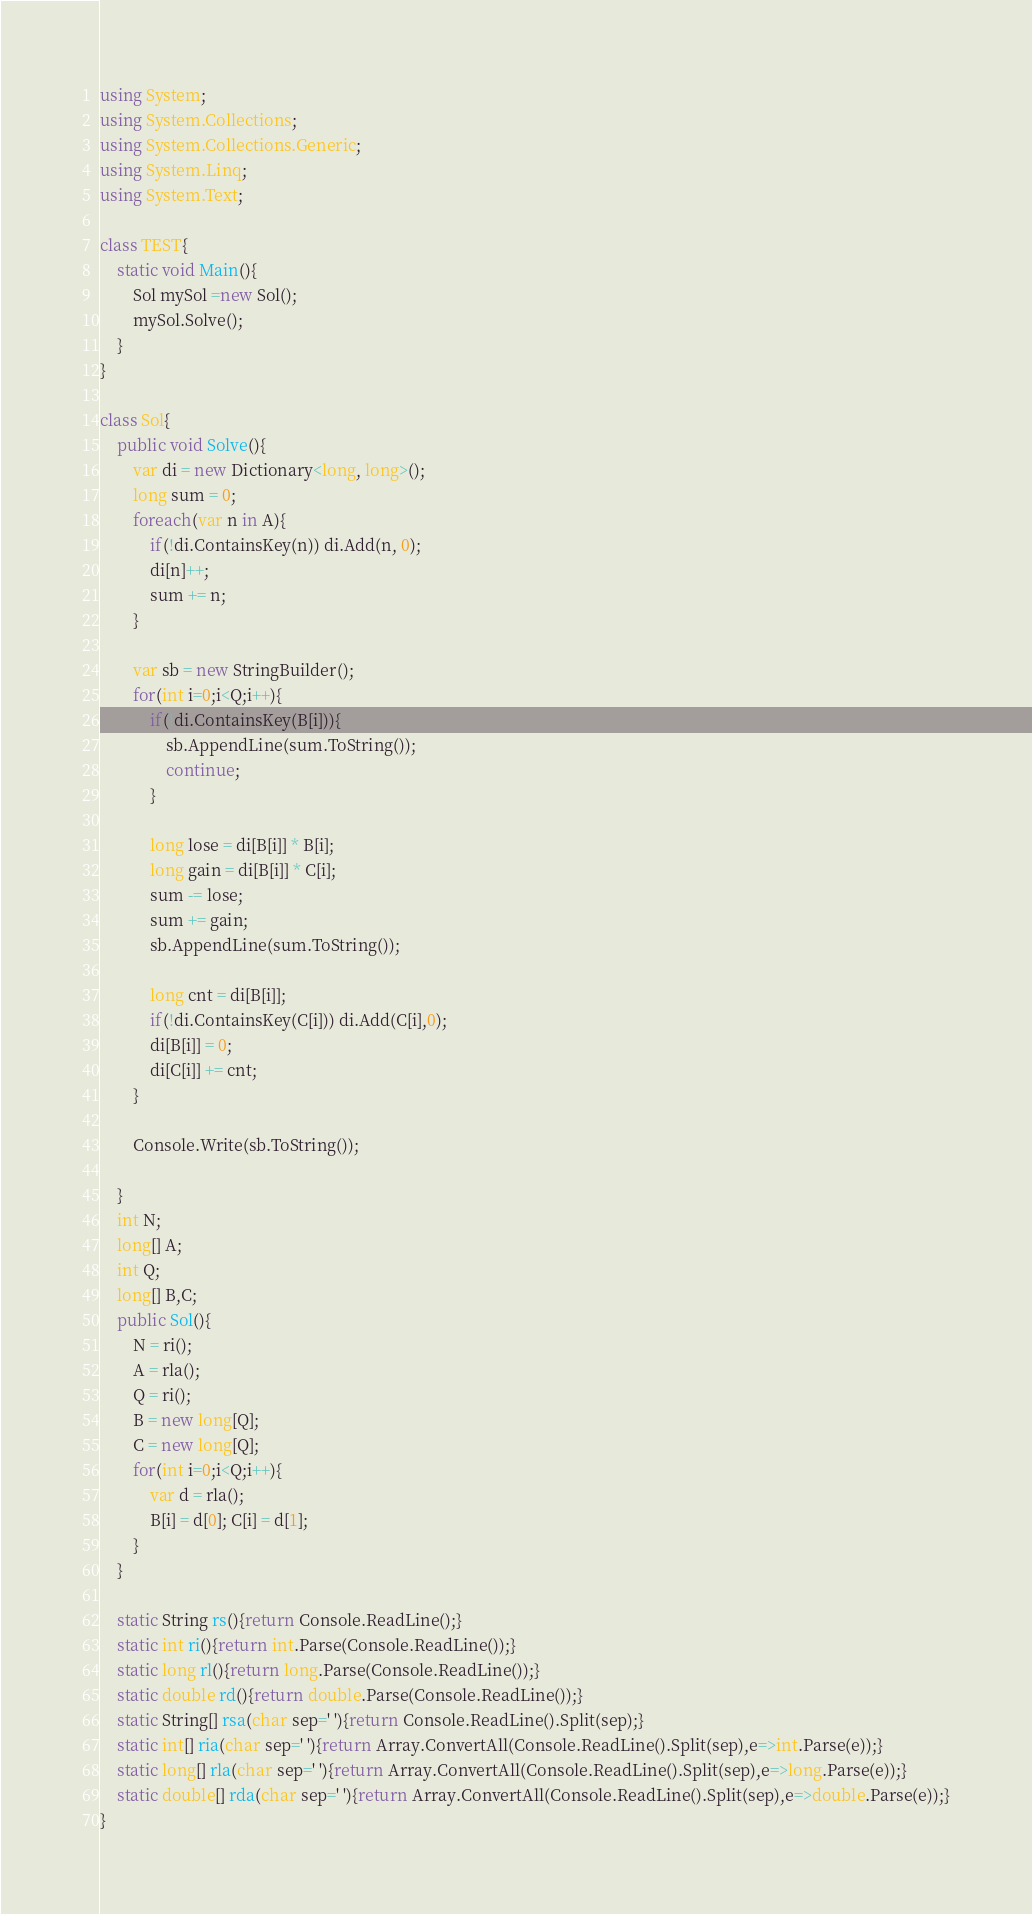<code> <loc_0><loc_0><loc_500><loc_500><_C#_>using System;
using System.Collections;
using System.Collections.Generic;
using System.Linq;
using System.Text;

class TEST{
	static void Main(){
		Sol mySol =new Sol();
		mySol.Solve();
	}
}

class Sol{
	public void Solve(){
		var di = new Dictionary<long, long>();
		long sum = 0;
		foreach(var n in A){
			if(!di.ContainsKey(n)) di.Add(n, 0);
			di[n]++;
			sum += n;
		}
		
		var sb = new StringBuilder();
		for(int i=0;i<Q;i++){
			if(!di.ContainsKey(B[i])){
				sb.AppendLine(sum.ToString());
				continue;
			}
			
			long lose = di[B[i]] * B[i];
			long gain = di[B[i]] * C[i];
			sum -= lose;
			sum += gain;
			sb.AppendLine(sum.ToString());
			
			long cnt = di[B[i]];
			if(!di.ContainsKey(C[i])) di.Add(C[i],0);
			di[B[i]] = 0;
			di[C[i]] += cnt;
		}
		
		Console.Write(sb.ToString());
		
	}
	int N;
	long[] A;
	int Q;
	long[] B,C;
	public Sol(){
		N = ri();
		A = rla();
		Q = ri();
		B = new long[Q];
		C = new long[Q];
		for(int i=0;i<Q;i++){
			var d = rla();
			B[i] = d[0]; C[i] = d[1];
		}
	}

	static String rs(){return Console.ReadLine();}
	static int ri(){return int.Parse(Console.ReadLine());}
	static long rl(){return long.Parse(Console.ReadLine());}
	static double rd(){return double.Parse(Console.ReadLine());}
	static String[] rsa(char sep=' '){return Console.ReadLine().Split(sep);}
	static int[] ria(char sep=' '){return Array.ConvertAll(Console.ReadLine().Split(sep),e=>int.Parse(e));}
	static long[] rla(char sep=' '){return Array.ConvertAll(Console.ReadLine().Split(sep),e=>long.Parse(e));}
	static double[] rda(char sep=' '){return Array.ConvertAll(Console.ReadLine().Split(sep),e=>double.Parse(e));}
}
</code> 